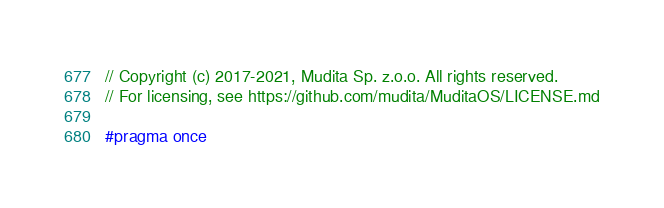<code> <loc_0><loc_0><loc_500><loc_500><_C++_>// Copyright (c) 2017-2021, Mudita Sp. z.o.o. All rights reserved.
// For licensing, see https://github.com/mudita/MuditaOS/LICENSE.md

#pragma once
</code> 